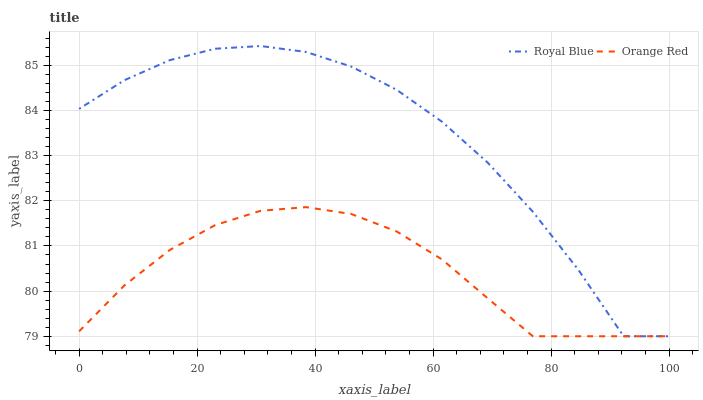Does Orange Red have the minimum area under the curve?
Answer yes or no. Yes. Does Royal Blue have the maximum area under the curve?
Answer yes or no. Yes. Does Orange Red have the maximum area under the curve?
Answer yes or no. No. Is Orange Red the smoothest?
Answer yes or no. Yes. Is Royal Blue the roughest?
Answer yes or no. Yes. Is Orange Red the roughest?
Answer yes or no. No. Does Royal Blue have the lowest value?
Answer yes or no. Yes. Does Royal Blue have the highest value?
Answer yes or no. Yes. Does Orange Red have the highest value?
Answer yes or no. No. Does Orange Red intersect Royal Blue?
Answer yes or no. Yes. Is Orange Red less than Royal Blue?
Answer yes or no. No. Is Orange Red greater than Royal Blue?
Answer yes or no. No. 